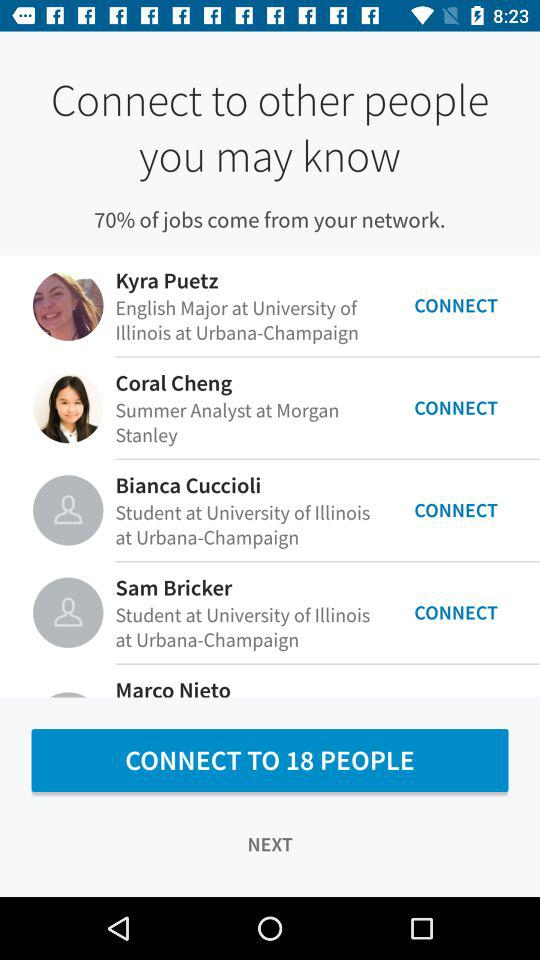Where does Bianca Cuccioli study? Bianca Cuccioli studies at "University of Illinois at Urbana-Champaign". 